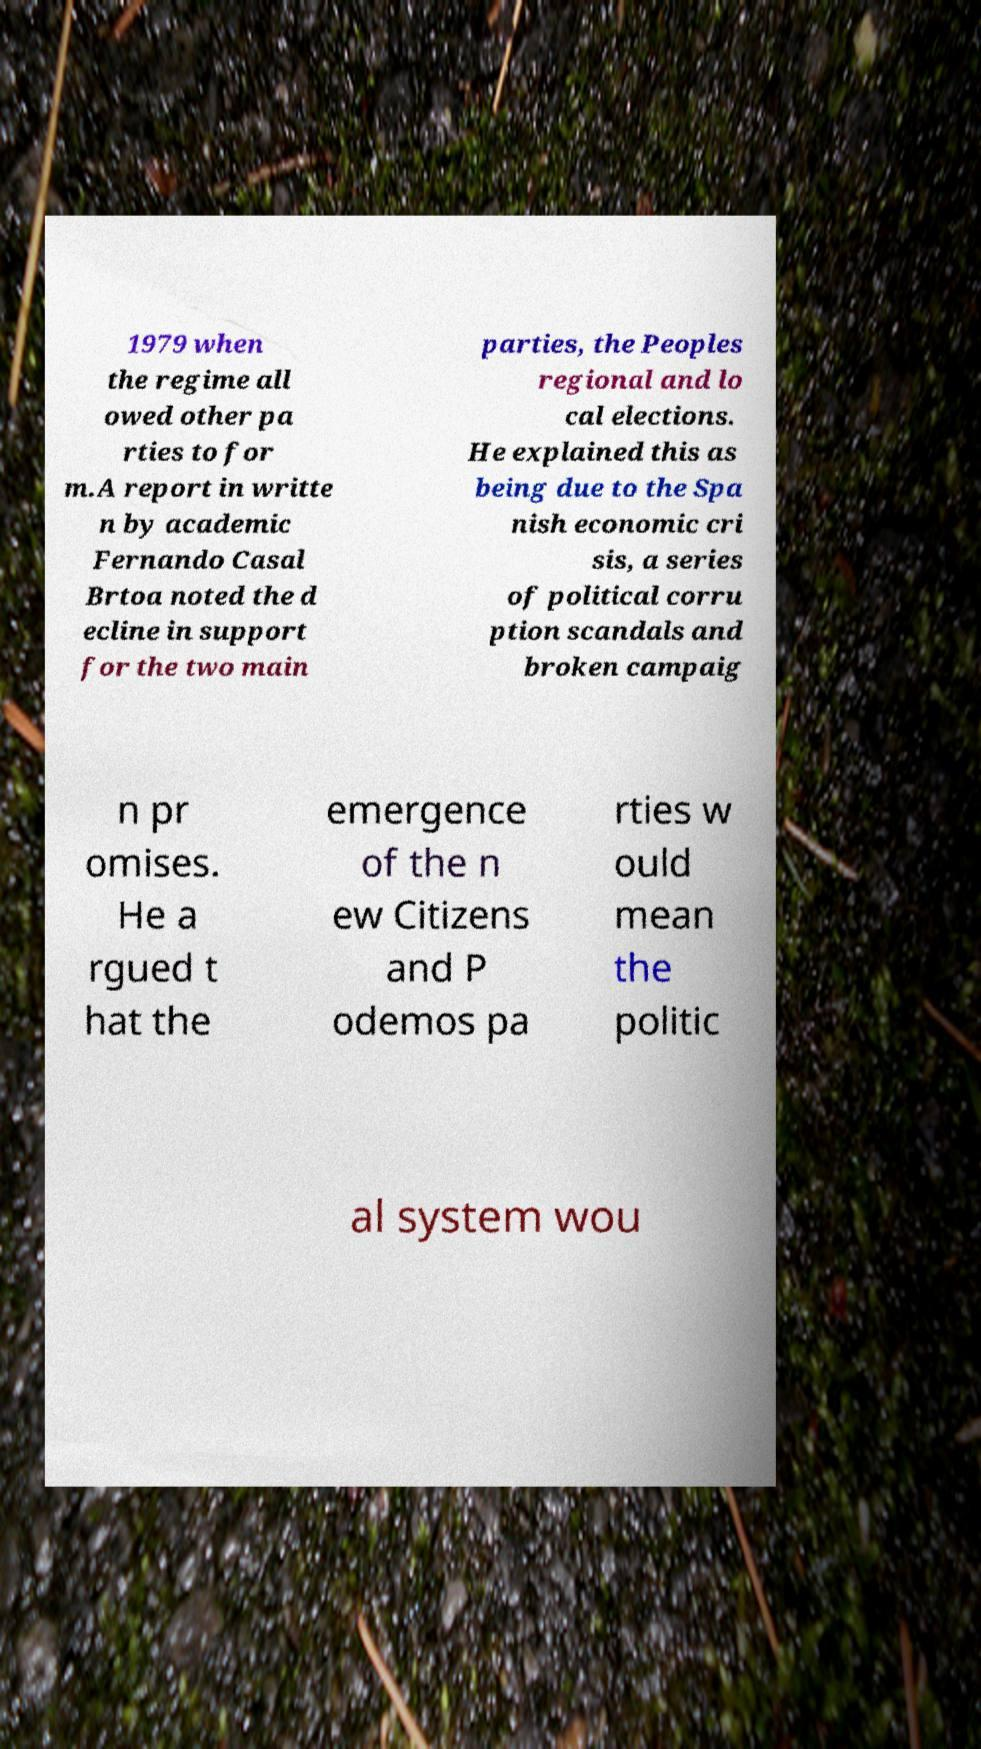I need the written content from this picture converted into text. Can you do that? 1979 when the regime all owed other pa rties to for m.A report in writte n by academic Fernando Casal Brtoa noted the d ecline in support for the two main parties, the Peoples regional and lo cal elections. He explained this as being due to the Spa nish economic cri sis, a series of political corru ption scandals and broken campaig n pr omises. He a rgued t hat the emergence of the n ew Citizens and P odemos pa rties w ould mean the politic al system wou 